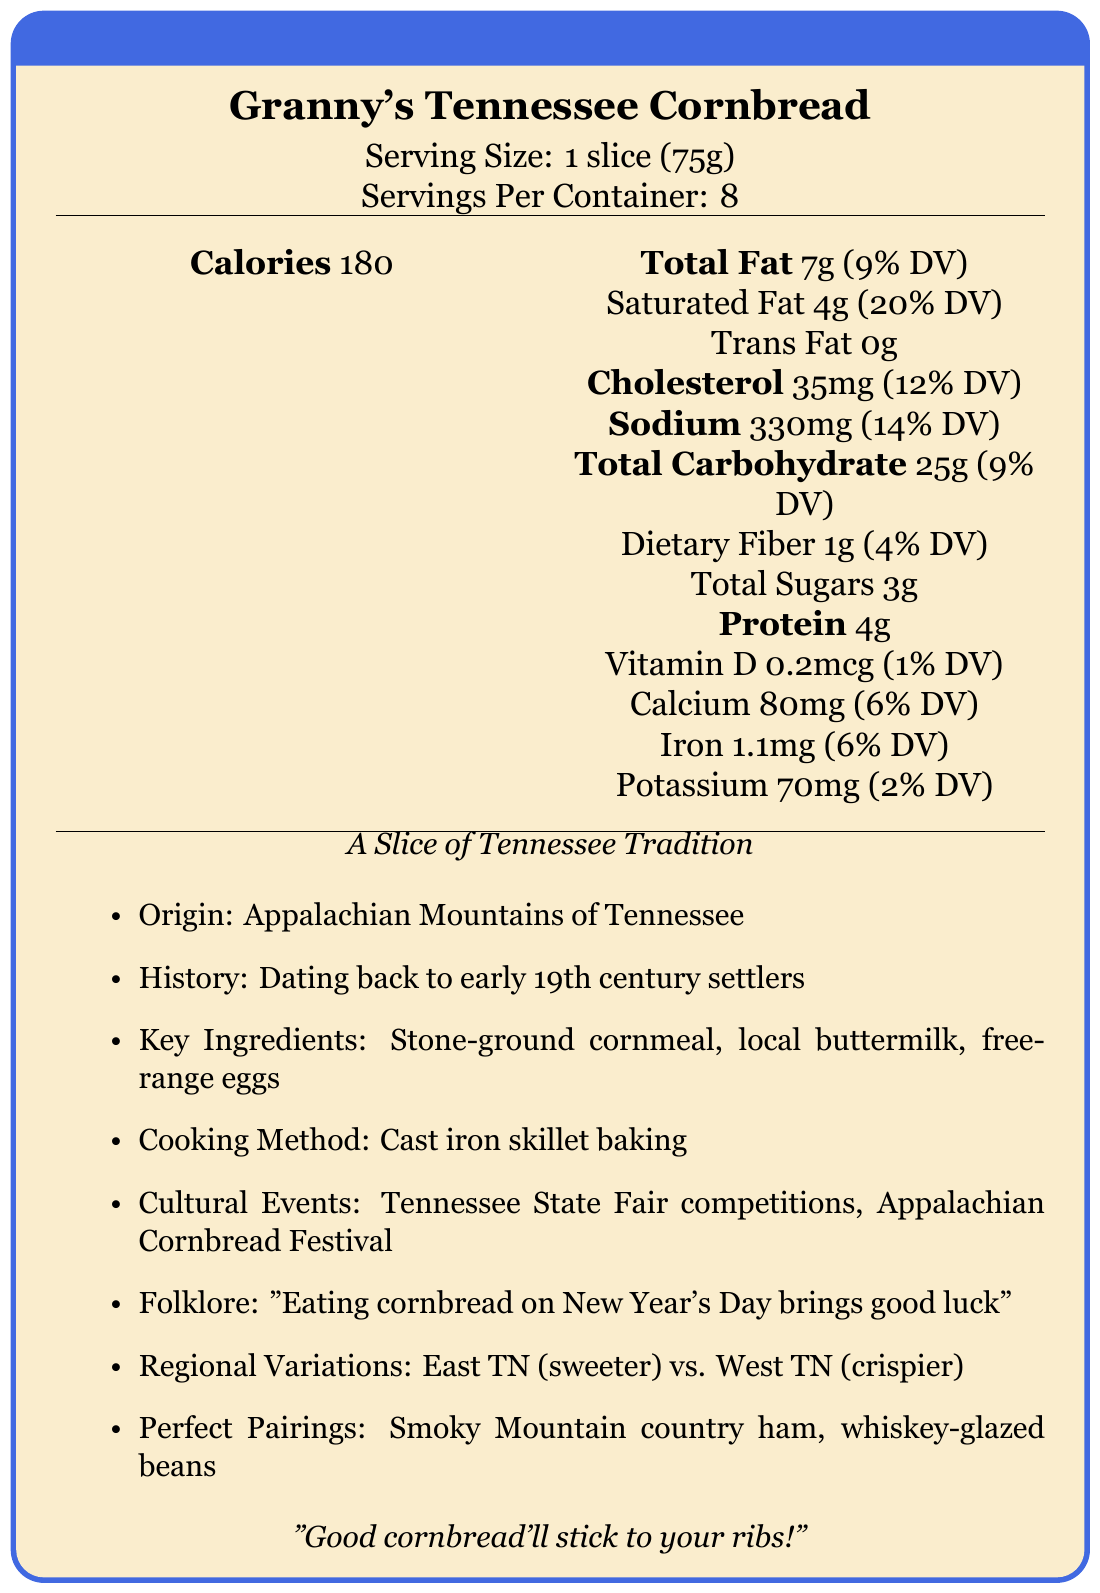what is the serving size? The serving size is explicitly mentioned as 1 slice (75g) in the document.
Answer: 1 slice (75g) how many calories are there in one serving? The document states that there are 180 calories in one serving.
Answer: 180 what percentage of the daily value does total fat represent? The document lists the total fat content as 7g, which is 9% of the daily value.
Answer: 9% what percentage of the daily value does calcium represent? According to the document, the calcium amount is 80mg, which is 6% of the daily value.
Answer: 6% which ingredient is traditionally used in the cornbread recipe?
A. Olive oil
B. Stone-ground cornmeal
C. White sugar
D. Almond milk The cultural significance section reveals that stone-ground cornmeal from local Smoky Mountain mills is a traditional ingredient.
Answer: B how is the cornbread traditionally cooked? The document specifies that the traditional cooking method is cast iron skillet baking.
Answer: Cast iron skillet baking what cultural event features cornbread competitions? The document lists the Tennessee State Fair as an event that features cornbread competitions.
Answer: Tennessee State Fair what folklore is associated with eating cornbread? The folklore section mentions that eating cornbread on New Year's Day is believed to bring good luck.
Answer: Eating cornbread on New Year's Day brings good luck what are the regional variations of cornbread in Tennessee? The document details that East Tennessee cornbread is sweeter with a cake-like texture, whereas West Tennessee cornbread has a crispier crust and less sugar.
Answer: East Tennessee: Sweeter, cake-like texture; West Tennessee: Crispier crust, less sugar is there any trans fat in Granny's Tennessee Cornbread? The document states that the trans fat content is 0g.
Answer: No which pairing is suggested with Granny's Tennessee Cornbread?
1. French wine
2. Tennessee whiskey-glazed beans
3. Italian pasta The document suggests pairing the cornbread with Tennessee whiskey-glazed beans.
Answer: 2 what is the origin of Granny's Tennessee Cornbread? The document mentions that the origin of this cornbread recipe is the Appalachian Mountains of Tennessee.
Answer: Appalachian Mountains of Tennessee when did settlers begin making cornbread in Tennessee? The document's history section states that the tradition dates back to early 19th century settlers.
Answer: Early 19th century is vitamin C present in the cornbread? The document does not mention the presence or the amount of vitamin C in the cornbread.
Answer: Not enough information summarize the document. The document is divided into sections detailing the nutritional information of the cornbread and its cultural significance, including historical context, traditional preparation methods, and associated folklore and events. This comprehensive overview ties the food item to its Tennessee heritage.
Answer: The document provides a detailed description of Granny's Tennessee Cornbread, covering its nutrition facts, cultural significance, traditional ingredients, cooking method, folklore, regional variations, and suggested pairings. The cornbread, made from stone-ground cornmeal, buttermilk, and free-range eggs, is baked in a cast iron skillet and has deep roots in the Appalachian Mountains. Cultural events, regional differences, and traditional Southern pairings are highlighted. 